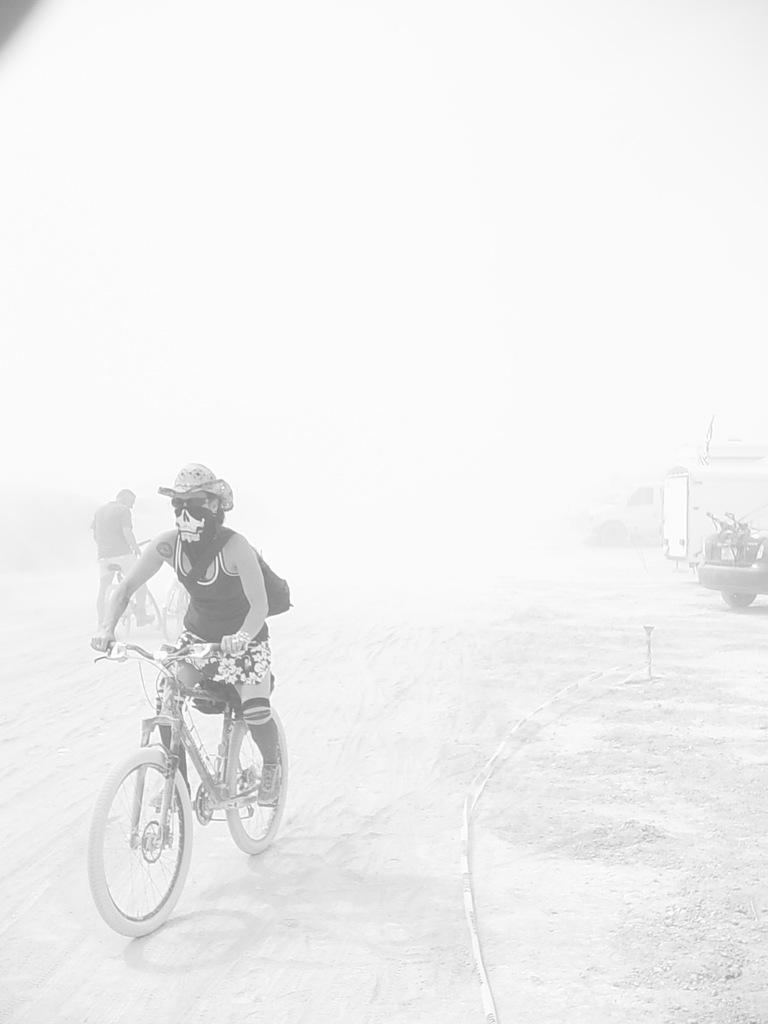What is the main subject of the image? There is a person riding a bicycle in the image. What is the second person doing in the image? The second person is holding a bicycle. What other vehicle is visible in the image? There is a car on the right side of the image. What type of rod is being used to control the society in the image? There is no rod or indication of controlling society in the image. The image features a person riding a bicycle, another person holding a bicycle, and a car on the right side. 